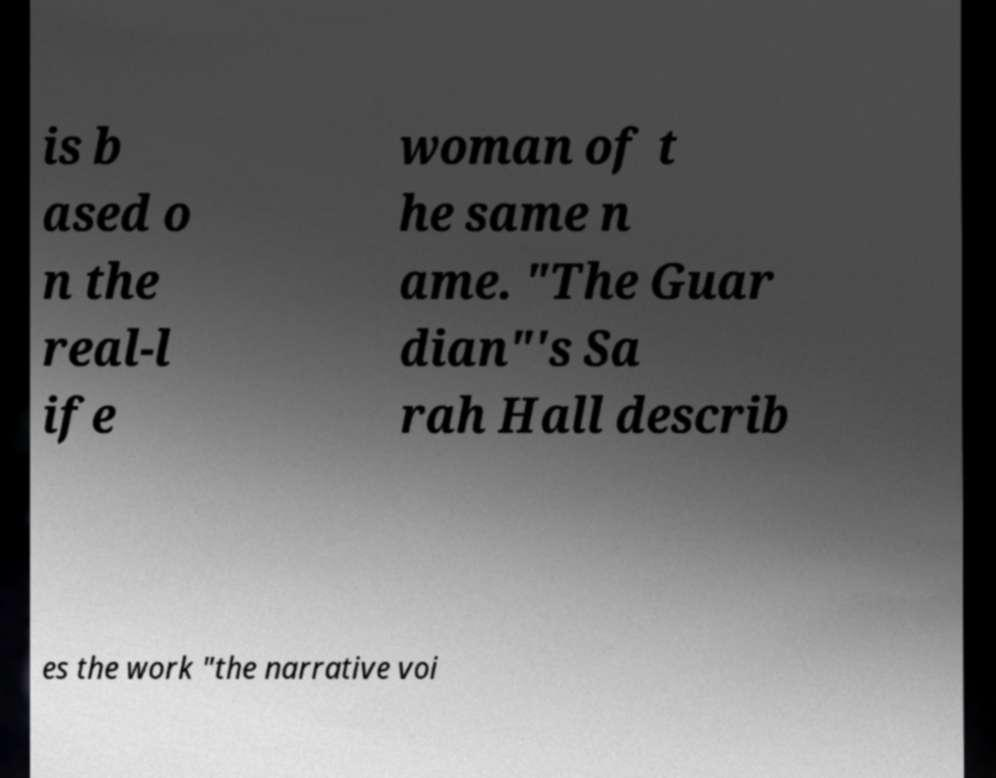I need the written content from this picture converted into text. Can you do that? is b ased o n the real-l ife woman of t he same n ame. "The Guar dian"'s Sa rah Hall describ es the work "the narrative voi 